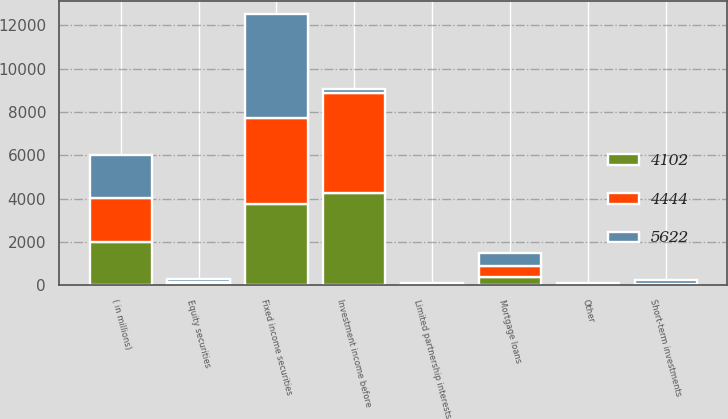Convert chart to OTSL. <chart><loc_0><loc_0><loc_500><loc_500><stacked_bar_chart><ecel><fcel>( in millions)<fcel>Fixed income securities<fcel>Equity securities<fcel>Mortgage loans<fcel>Limited partnership interests<fcel>Short-term investments<fcel>Other<fcel>Investment income before<nl><fcel>4102<fcel>2010<fcel>3737<fcel>90<fcel>385<fcel>40<fcel>8<fcel>19<fcel>4279<nl><fcel>4444<fcel>2009<fcel>3998<fcel>80<fcel>498<fcel>17<fcel>27<fcel>10<fcel>4610<nl><fcel>5622<fcel>2008<fcel>4783<fcel>120<fcel>618<fcel>62<fcel>195<fcel>54<fcel>195<nl></chart> 